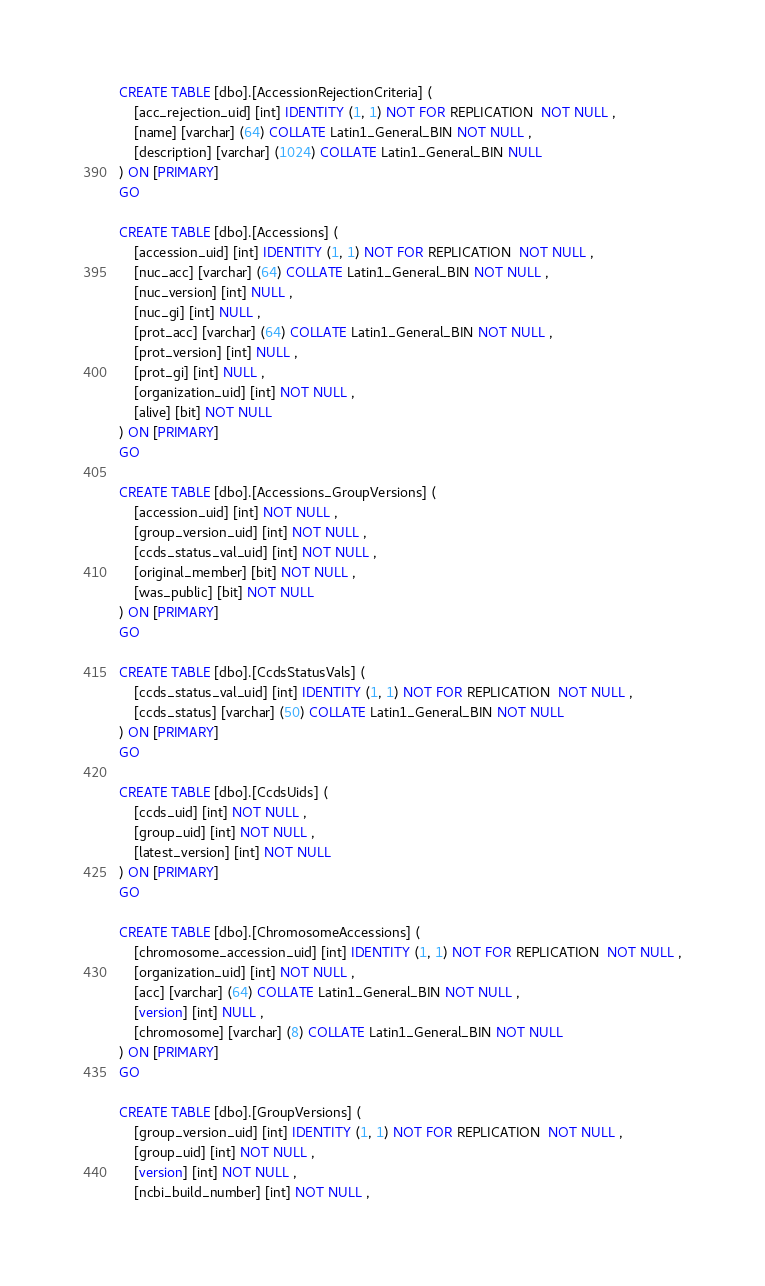<code> <loc_0><loc_0><loc_500><loc_500><_SQL_>CREATE TABLE [dbo].[AccessionRejectionCriteria] (
	[acc_rejection_uid] [int] IDENTITY (1, 1) NOT FOR REPLICATION  NOT NULL ,
	[name] [varchar] (64) COLLATE Latin1_General_BIN NOT NULL ,
	[description] [varchar] (1024) COLLATE Latin1_General_BIN NULL 
) ON [PRIMARY]
GO

CREATE TABLE [dbo].[Accessions] (
	[accession_uid] [int] IDENTITY (1, 1) NOT FOR REPLICATION  NOT NULL ,
	[nuc_acc] [varchar] (64) COLLATE Latin1_General_BIN NOT NULL ,
	[nuc_version] [int] NULL ,
	[nuc_gi] [int] NULL ,
	[prot_acc] [varchar] (64) COLLATE Latin1_General_BIN NOT NULL ,
	[prot_version] [int] NULL ,
	[prot_gi] [int] NULL ,
	[organization_uid] [int] NOT NULL ,
	[alive] [bit] NOT NULL 
) ON [PRIMARY]
GO

CREATE TABLE [dbo].[Accessions_GroupVersions] (
	[accession_uid] [int] NOT NULL ,
	[group_version_uid] [int] NOT NULL ,
	[ccds_status_val_uid] [int] NOT NULL ,
	[original_member] [bit] NOT NULL ,
	[was_public] [bit] NOT NULL 
) ON [PRIMARY]
GO

CREATE TABLE [dbo].[CcdsStatusVals] (
	[ccds_status_val_uid] [int] IDENTITY (1, 1) NOT FOR REPLICATION  NOT NULL ,
	[ccds_status] [varchar] (50) COLLATE Latin1_General_BIN NOT NULL 
) ON [PRIMARY]
GO

CREATE TABLE [dbo].[CcdsUids] (
	[ccds_uid] [int] NOT NULL ,
	[group_uid] [int] NOT NULL ,
	[latest_version] [int] NOT NULL 
) ON [PRIMARY]
GO

CREATE TABLE [dbo].[ChromosomeAccessions] (
	[chromosome_accession_uid] [int] IDENTITY (1, 1) NOT FOR REPLICATION  NOT NULL ,
	[organization_uid] [int] NOT NULL ,
	[acc] [varchar] (64) COLLATE Latin1_General_BIN NOT NULL ,
	[version] [int] NULL ,
	[chromosome] [varchar] (8) COLLATE Latin1_General_BIN NOT NULL 
) ON [PRIMARY]
GO

CREATE TABLE [dbo].[GroupVersions] (
	[group_version_uid] [int] IDENTITY (1, 1) NOT FOR REPLICATION  NOT NULL ,
	[group_uid] [int] NOT NULL ,
	[version] [int] NOT NULL ,
	[ncbi_build_number] [int] NOT NULL ,</code> 